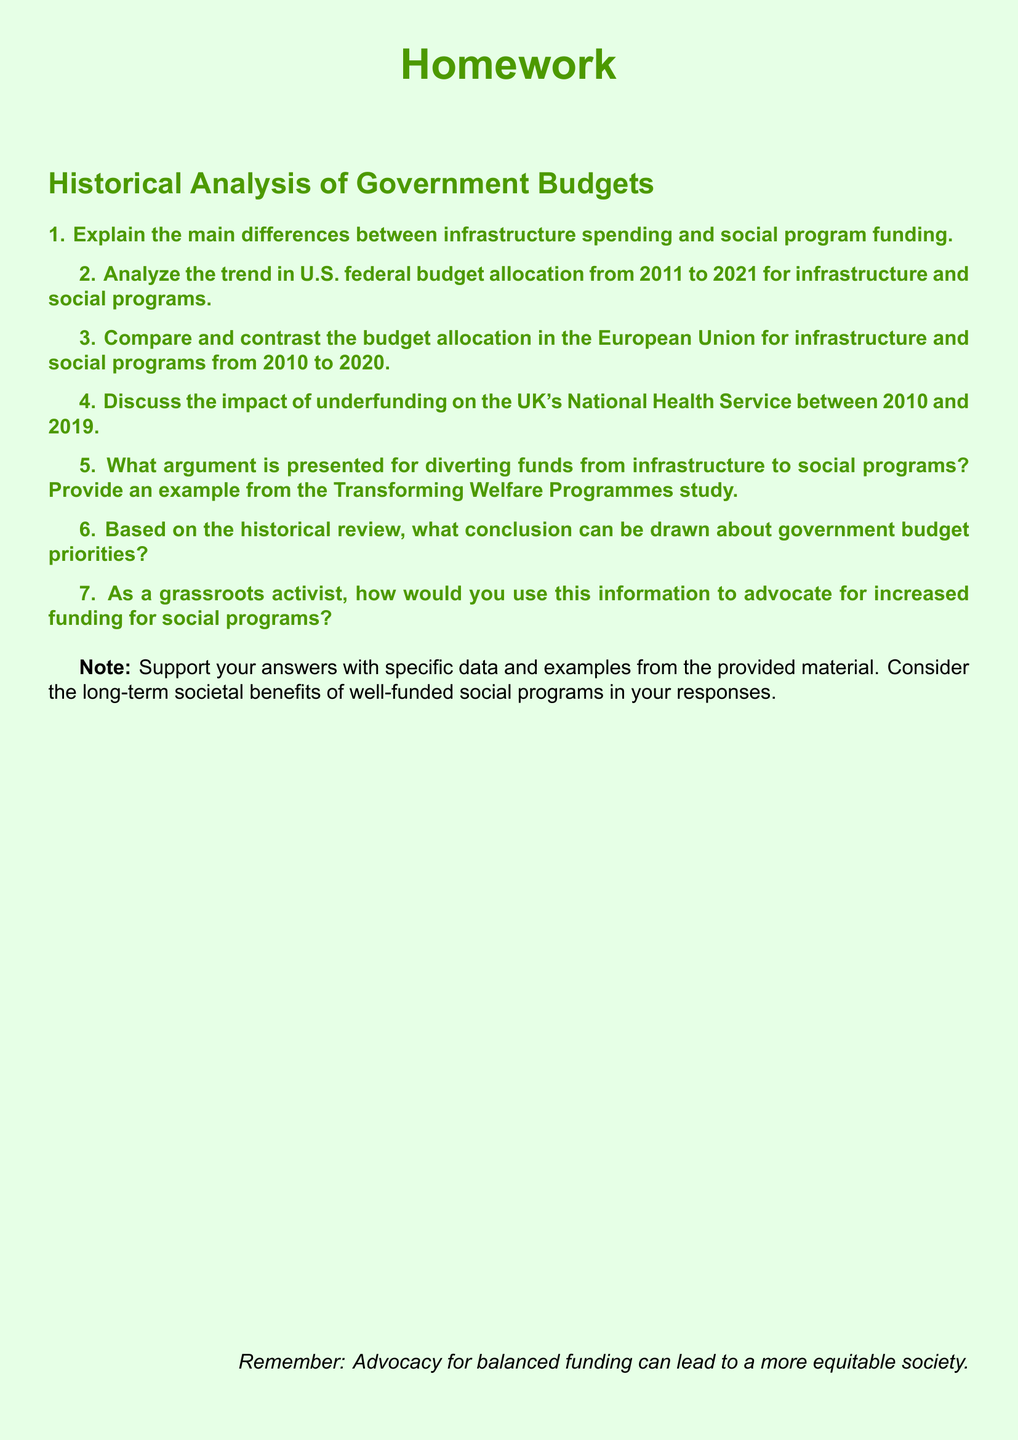What is the main focus of the homework? The main focus is on the historical analysis of government budgets, specifically comparing infrastructure spending and social program funding over the past decade.
Answer: Historical Analysis of Government Budgets What years are analyzed for the U.S. federal budget allocation? The years analyzed for the U.S. federal budget allocation are from 2011 to 2021.
Answer: 2011 to 2021 Which country’s National Health Service is discussed in the context of underfunding? The document discusses the United Kingdom's National Health Service.
Answer: United Kingdom What type of programs does the homework suggest diverting funds to? The homework suggests diverting funds to social programs.
Answer: Social programs What is one specific example used in the homework to support the argument for fund diversion? The example used is from the Transforming Welfare Programmes study.
Answer: Transforming Welfare Programmes study What is advised in the note at the end of the document? The note advises that advocacy for balanced funding can lead to a more equitable society.
Answer: Advocacy for balanced funding can lead to a more equitable society 